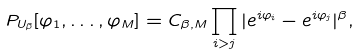<formula> <loc_0><loc_0><loc_500><loc_500>P _ { U _ { \beta } } [ \varphi _ { 1 } , \dots , \varphi _ { M } ] = C _ { \beta , M } \prod _ { i > j } | e ^ { i \varphi _ { i } } - e ^ { i \varphi _ { j } } | ^ { \beta } ,</formula> 